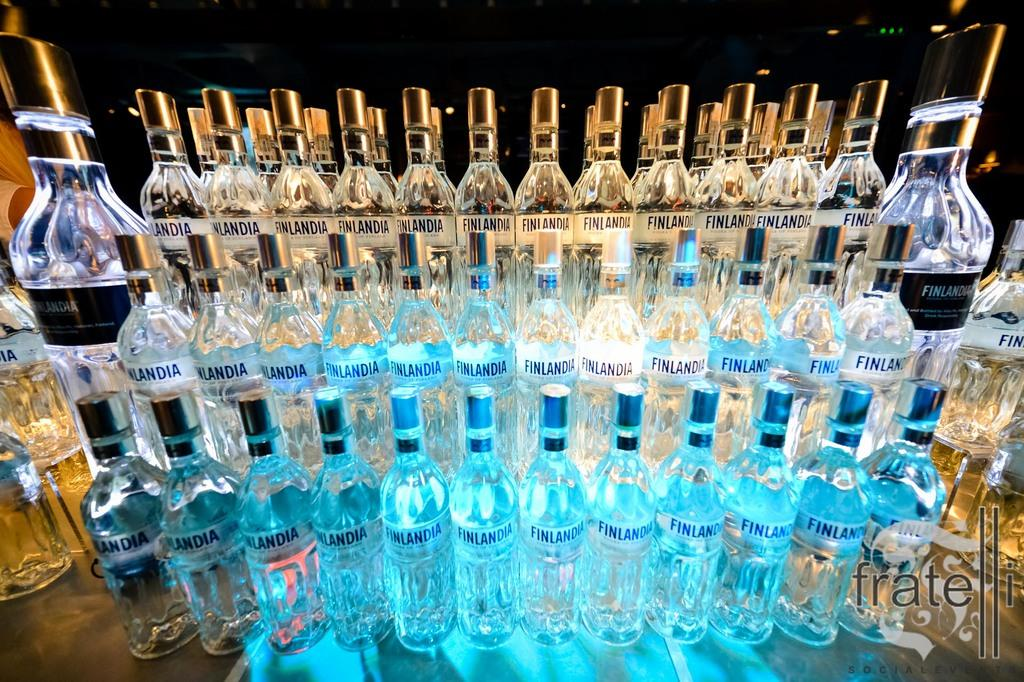What objects can be seen in the image? There are bottles in the image. What type of art is displayed on the bottles in the image? There is no information about any art on the bottles in the image. Can you see a comb being used with the bottles in the image? There is no comb present in the image. 